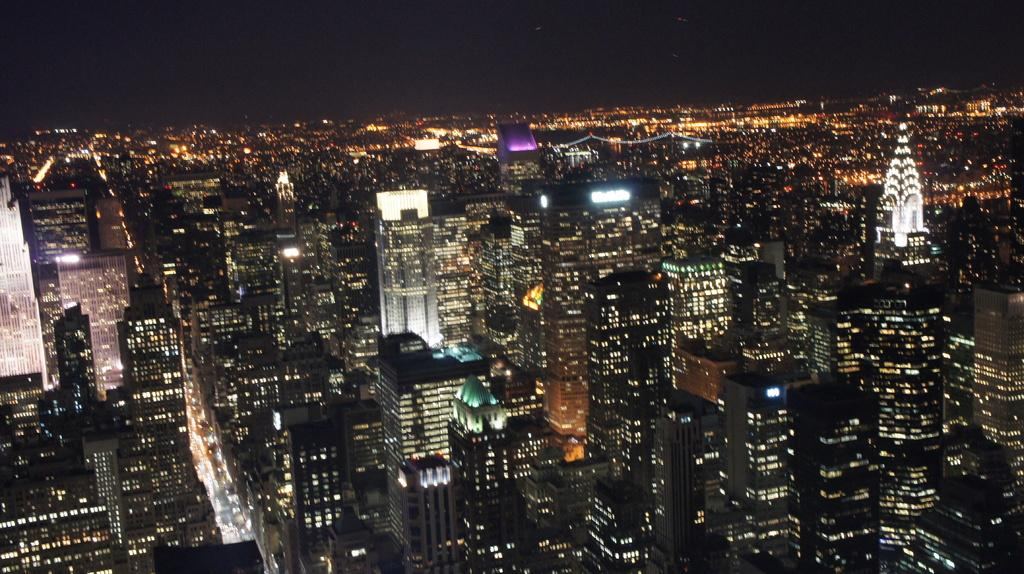What perspective is the image taken from? The image provides a top view of the city. What can be seen in the image from this perspective? There are many buildings visible in the image. Are there any other features visible in the image besides the buildings? Yes, there are lights visible in the image. How many sheep can be seen grazing in the image? There are no sheep present in the image; it shows a top view of a city with buildings and lights. 